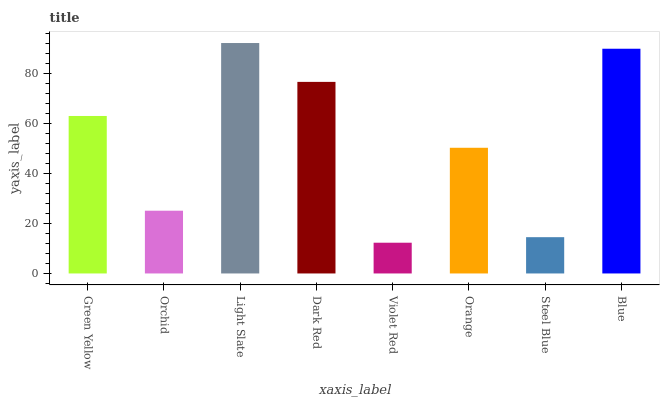Is Violet Red the minimum?
Answer yes or no. Yes. Is Light Slate the maximum?
Answer yes or no. Yes. Is Orchid the minimum?
Answer yes or no. No. Is Orchid the maximum?
Answer yes or no. No. Is Green Yellow greater than Orchid?
Answer yes or no. Yes. Is Orchid less than Green Yellow?
Answer yes or no. Yes. Is Orchid greater than Green Yellow?
Answer yes or no. No. Is Green Yellow less than Orchid?
Answer yes or no. No. Is Green Yellow the high median?
Answer yes or no. Yes. Is Orange the low median?
Answer yes or no. Yes. Is Orchid the high median?
Answer yes or no. No. Is Dark Red the low median?
Answer yes or no. No. 